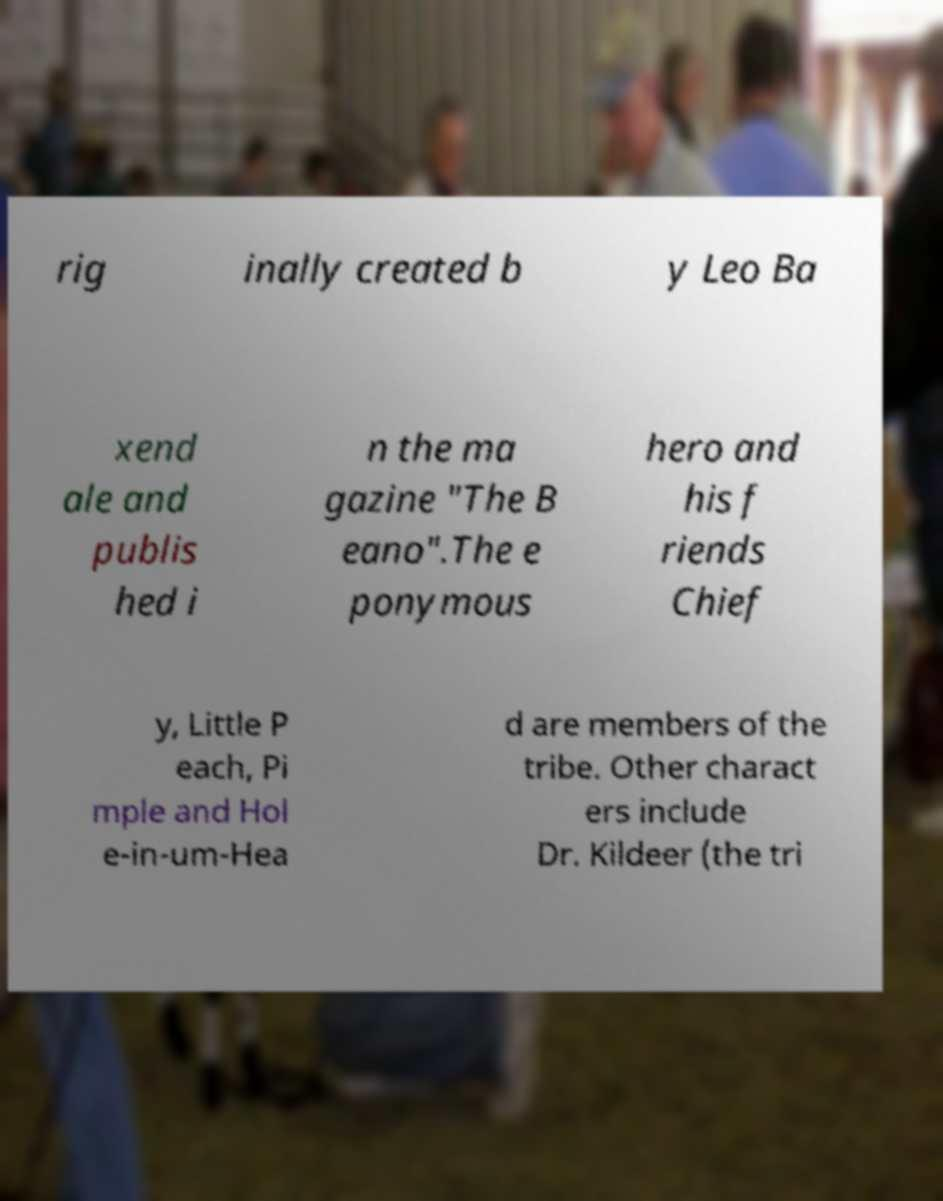There's text embedded in this image that I need extracted. Can you transcribe it verbatim? rig inally created b y Leo Ba xend ale and publis hed i n the ma gazine "The B eano".The e ponymous hero and his f riends Chief y, Little P each, Pi mple and Hol e-in-um-Hea d are members of the tribe. Other charact ers include Dr. Kildeer (the tri 